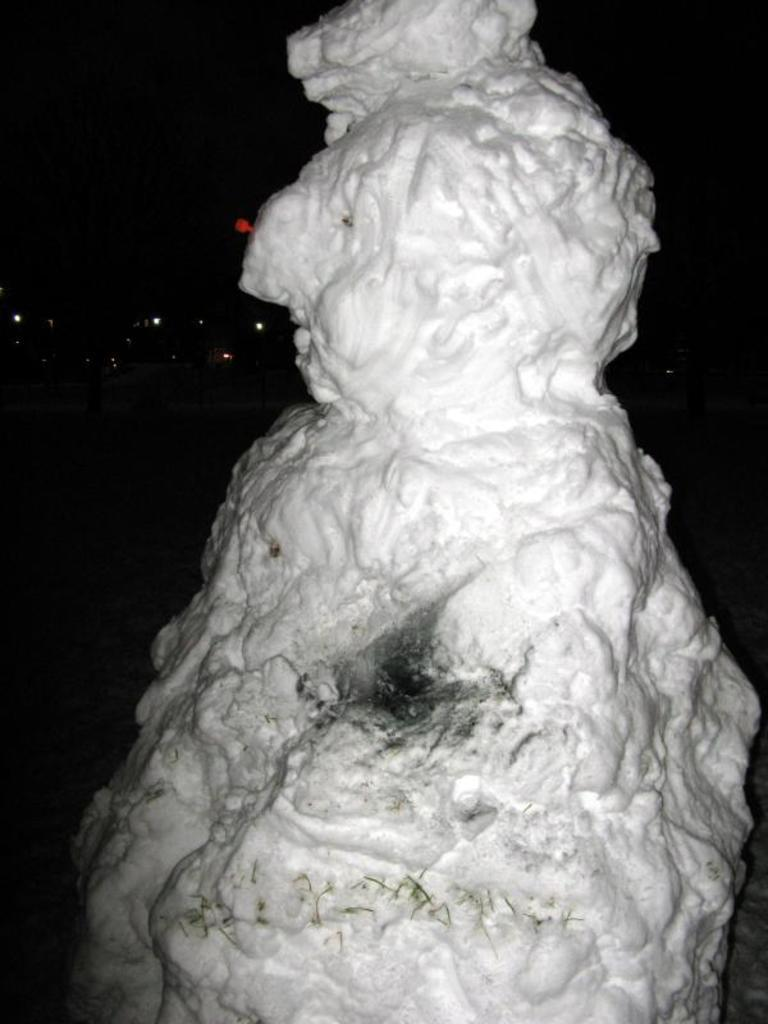What is the main subject of the image? There is a rock in the image. What can be seen in the background of the image? There are lights visible in the background of the image. What is the color of the background in the image? The background of the image appears to be black. What type of pen is being used to draw on the rock in the image? There is no pen or drawing present on the rock in the image. How many pails of water are visible near the rock in the image? There are no pails of water visible near the rock in the image. 